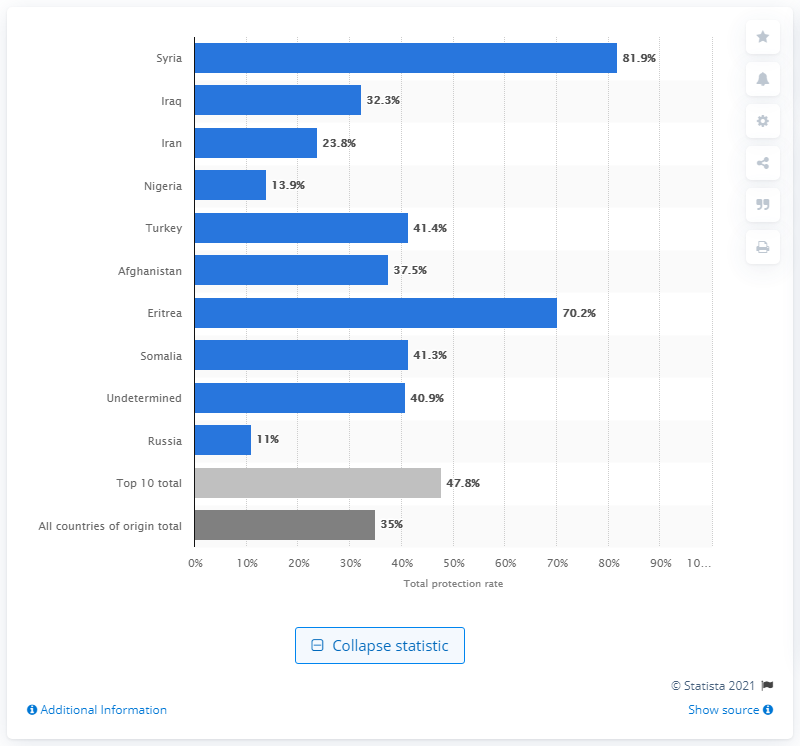Point out several critical features in this image. In 2018, the rate of recognition as refugees from Syria was 81.9%. 